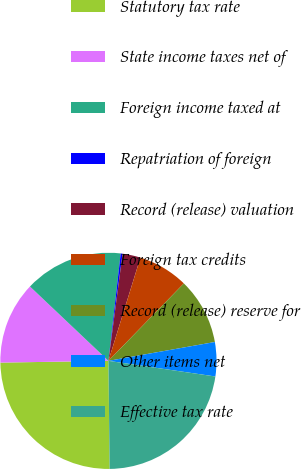<chart> <loc_0><loc_0><loc_500><loc_500><pie_chart><fcel>Statutory tax rate<fcel>State income taxes net of<fcel>Foreign income taxed at<fcel>Repatriation of foreign<fcel>Record (release) valuation<fcel>Foreign tax credits<fcel>Record (release) reserve for<fcel>Other items net<fcel>Effective tax rate<nl><fcel>24.92%<fcel>12.33%<fcel>14.74%<fcel>0.28%<fcel>2.69%<fcel>7.51%<fcel>9.92%<fcel>5.1%<fcel>22.51%<nl></chart> 